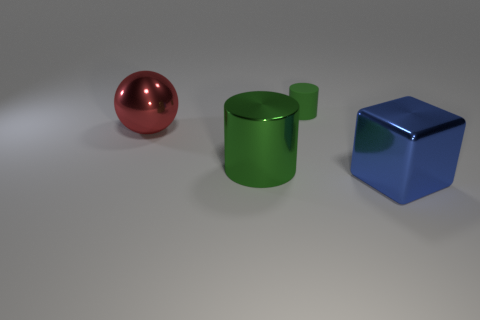Imagine these objects are part of a story. What role could each one play? In a story, these objects could represent characters or key plot elements. The shiny red sphere could be a magical orb filled with power, the green cylinder a container holding an ancient scroll, and the blue cube a puzzle box that unlocks a secret passage. Each object's unique properties could serve to drive different parts of the narrative. 